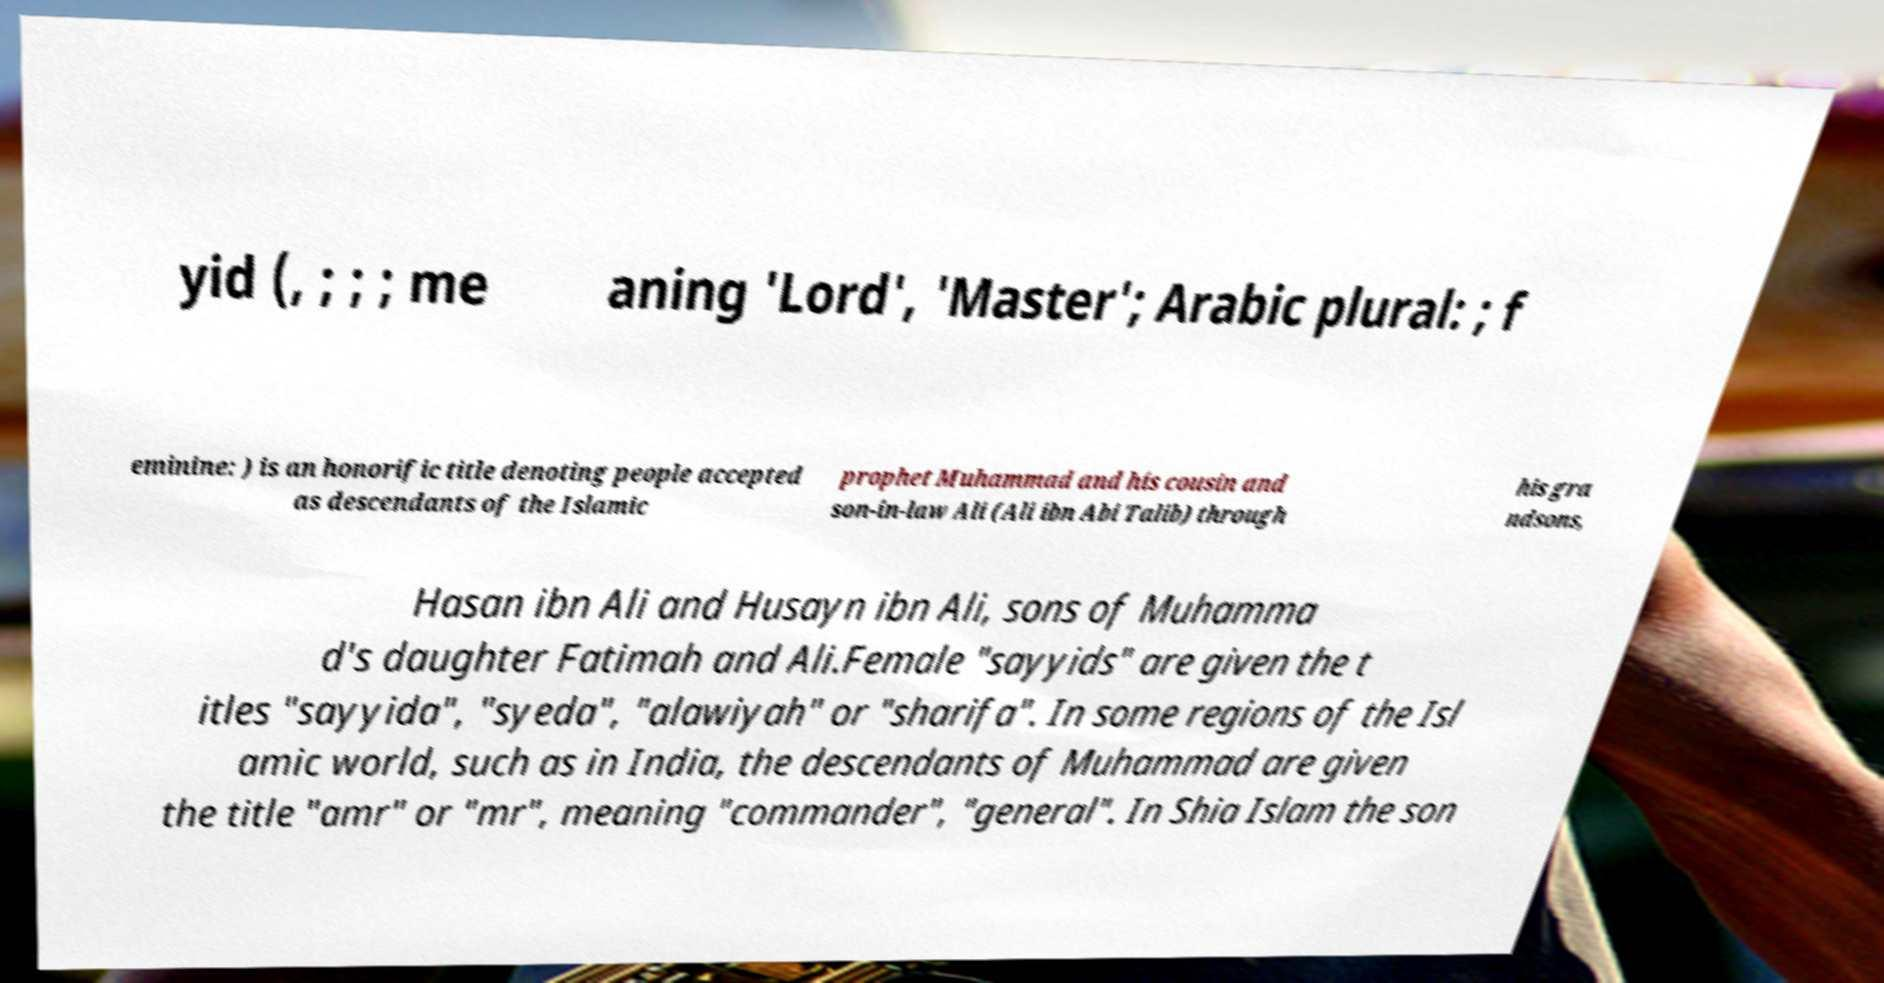For documentation purposes, I need the text within this image transcribed. Could you provide that? yid (, ; ; ; me aning 'Lord', 'Master'; Arabic plural: ; f eminine: ) is an honorific title denoting people accepted as descendants of the Islamic prophet Muhammad and his cousin and son-in-law Ali (Ali ibn Abi Talib) through his gra ndsons, Hasan ibn Ali and Husayn ibn Ali, sons of Muhamma d's daughter Fatimah and Ali.Female "sayyids" are given the t itles "sayyida", "syeda", "alawiyah" or "sharifa". In some regions of the Isl amic world, such as in India, the descendants of Muhammad are given the title "amr" or "mr", meaning "commander", "general". In Shia Islam the son 